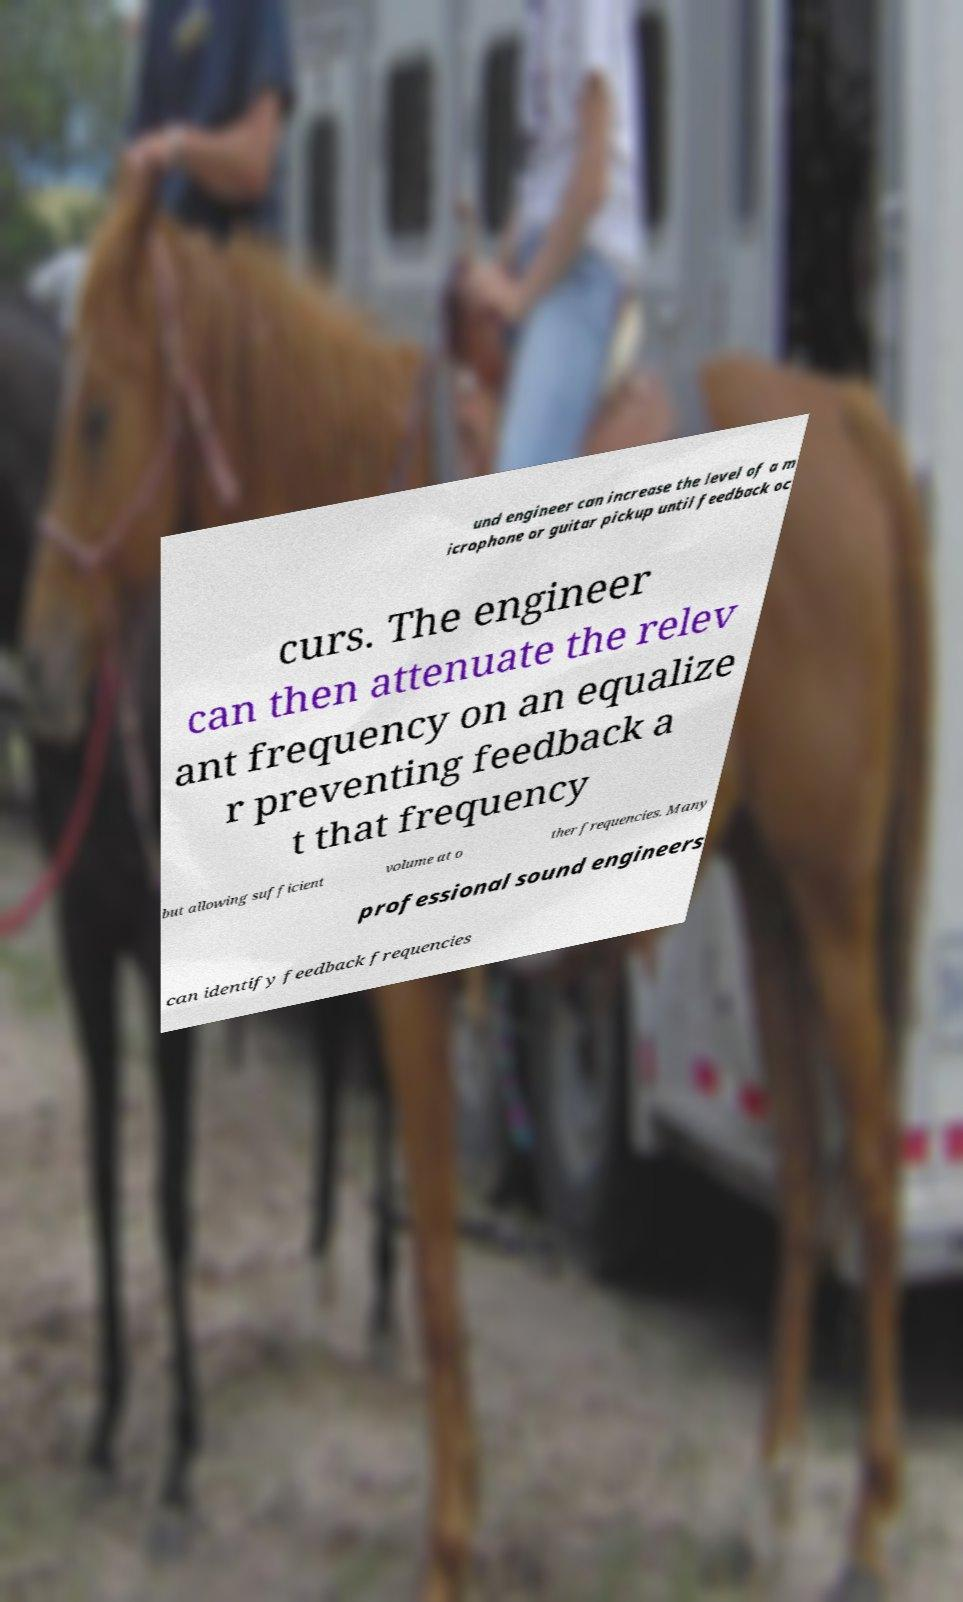I need the written content from this picture converted into text. Can you do that? und engineer can increase the level of a m icrophone or guitar pickup until feedback oc curs. The engineer can then attenuate the relev ant frequency on an equalize r preventing feedback a t that frequency but allowing sufficient volume at o ther frequencies. Many professional sound engineers can identify feedback frequencies 